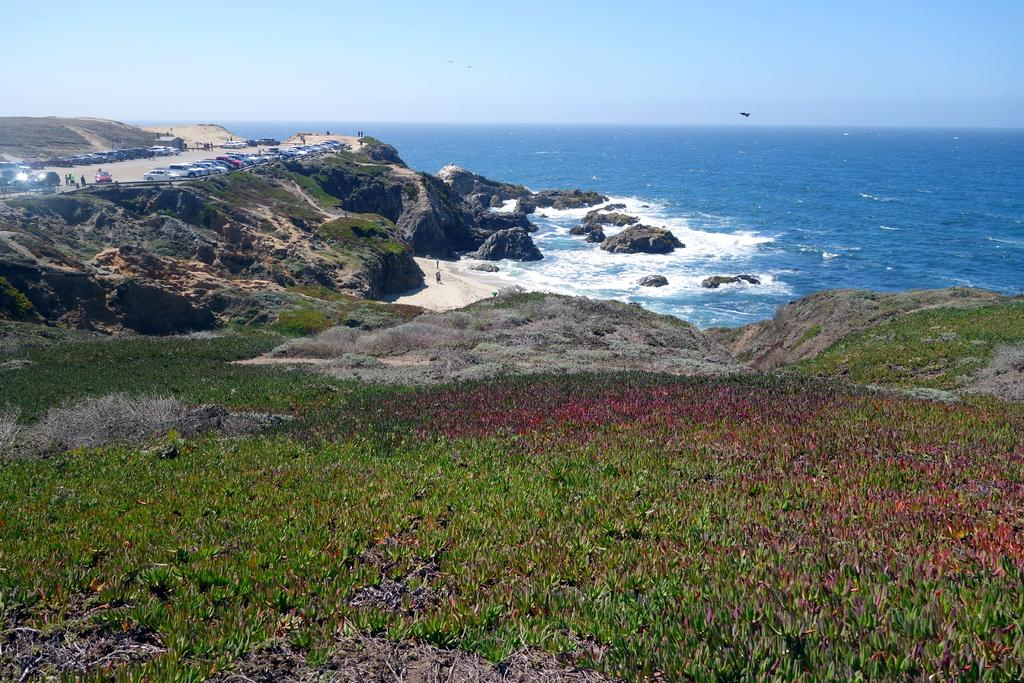What is present on the road in the image? There are vehicles on the road in the image. What type of vegetation can be seen in the image? There is grass visible in the image. What other natural elements are present in the image? There are rocks and water visible in the image. What can be seen in the background of the image? The sky is visible in the background of the image. What type of canvas is being used to paint the rocks in the image? There is no canvas or painting activity present in the image; it features vehicles on a road with grass, rocks, water, and a visible sky. How much rice is visible in the image? There is no rice present in the image. 